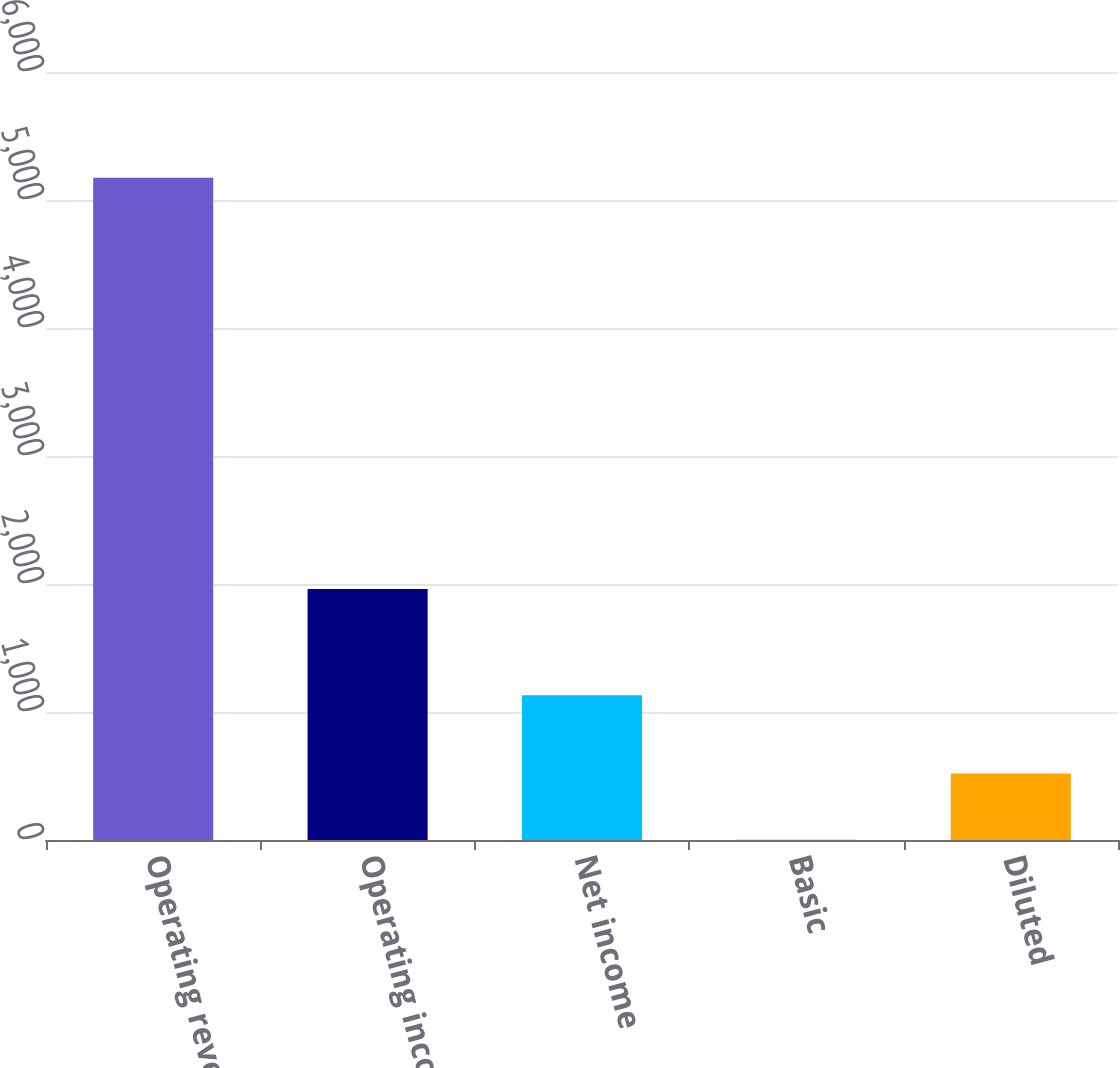<chart> <loc_0><loc_0><loc_500><loc_500><bar_chart><fcel>Operating revenues<fcel>Operating income<fcel>Net income<fcel>Basic<fcel>Diluted<nl><fcel>5174<fcel>1960<fcel>1131<fcel>1.36<fcel>518.62<nl></chart> 